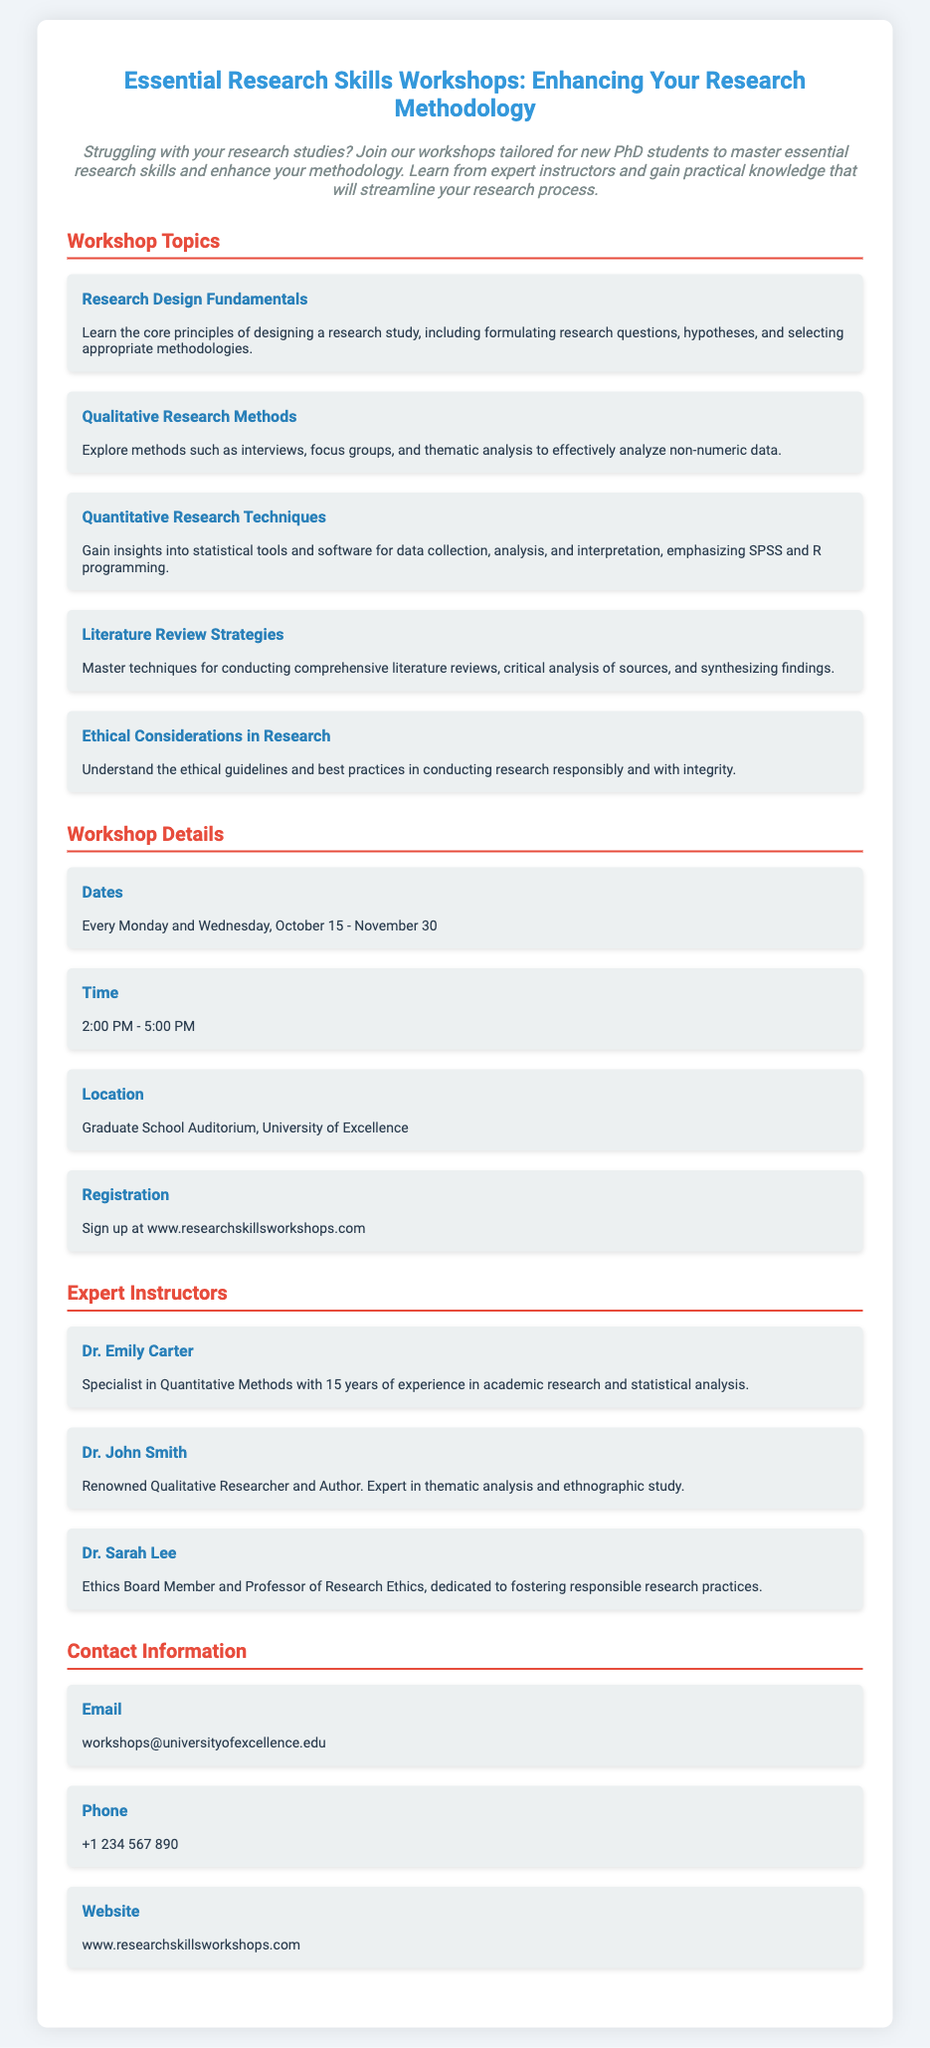What are the workshop dates? The document states that the workshops are scheduled for every Monday and Wednesday from October 15 to November 30.
Answer: Every Monday and Wednesday, October 15 - November 30 Who is the instructor for Quantitative Methods? The flyer lists Dr. Emily Carter as the specialist in Quantitative Methods.
Answer: Dr. Emily Carter What time do the workshops start? According to the document, the workshops begin at 2:00 PM.
Answer: 2:00 PM What is the location of the workshops? The flyer specifies that the workshops will be held at the Graduate School Auditorium, University of Excellence.
Answer: Graduate School Auditorium, University of Excellence What type of research methods are covered in the workshops? The document highlights topics including Qualitative and Quantitative Research Methods.
Answer: Qualitative and Quantitative Research Methods How can participants register for the workshops? The flyer directs interested individuals to sign up at the specified website.
Answer: www.researchskillsworkshops.com What is the email contact for workshop inquiries? The flyer provides the email address for contact regarding the workshops.
Answer: workshops@universityofexcellence.edu Who focuses on Research Ethics in the workshops? The document mentions Dr. Sarah Lee as the instructor who focuses on ethics.
Answer: Dr. Sarah Lee What is an example of a qualitative research method discussed? The flyer lists interviews as one of the methods covered under qualitative research.
Answer: Interviews 